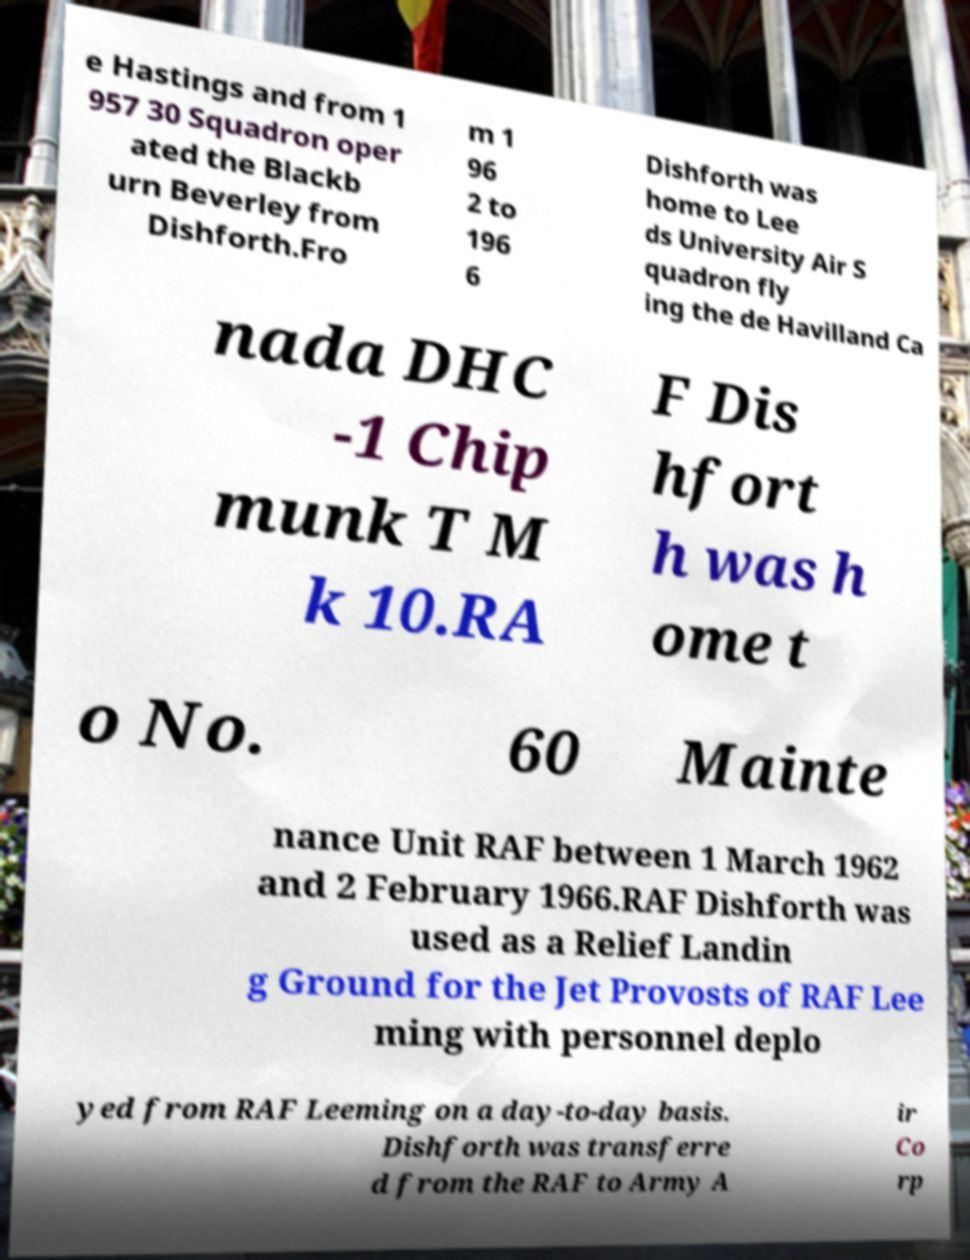Can you read and provide the text displayed in the image?This photo seems to have some interesting text. Can you extract and type it out for me? e Hastings and from 1 957 30 Squadron oper ated the Blackb urn Beverley from Dishforth.Fro m 1 96 2 to 196 6 Dishforth was home to Lee ds University Air S quadron fly ing the de Havilland Ca nada DHC -1 Chip munk T M k 10.RA F Dis hfort h was h ome t o No. 60 Mainte nance Unit RAF between 1 March 1962 and 2 February 1966.RAF Dishforth was used as a Relief Landin g Ground for the Jet Provosts of RAF Lee ming with personnel deplo yed from RAF Leeming on a day-to-day basis. Dishforth was transferre d from the RAF to Army A ir Co rp 